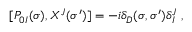<formula> <loc_0><loc_0><loc_500><loc_500>[ P _ { 0 I } ( \sigma ) , X ^ { J } ( \sigma ^ { \prime } ) ] = - i \delta _ { D } ( \sigma , \sigma ^ { \prime } ) \delta _ { I } ^ { J } \ ,</formula> 